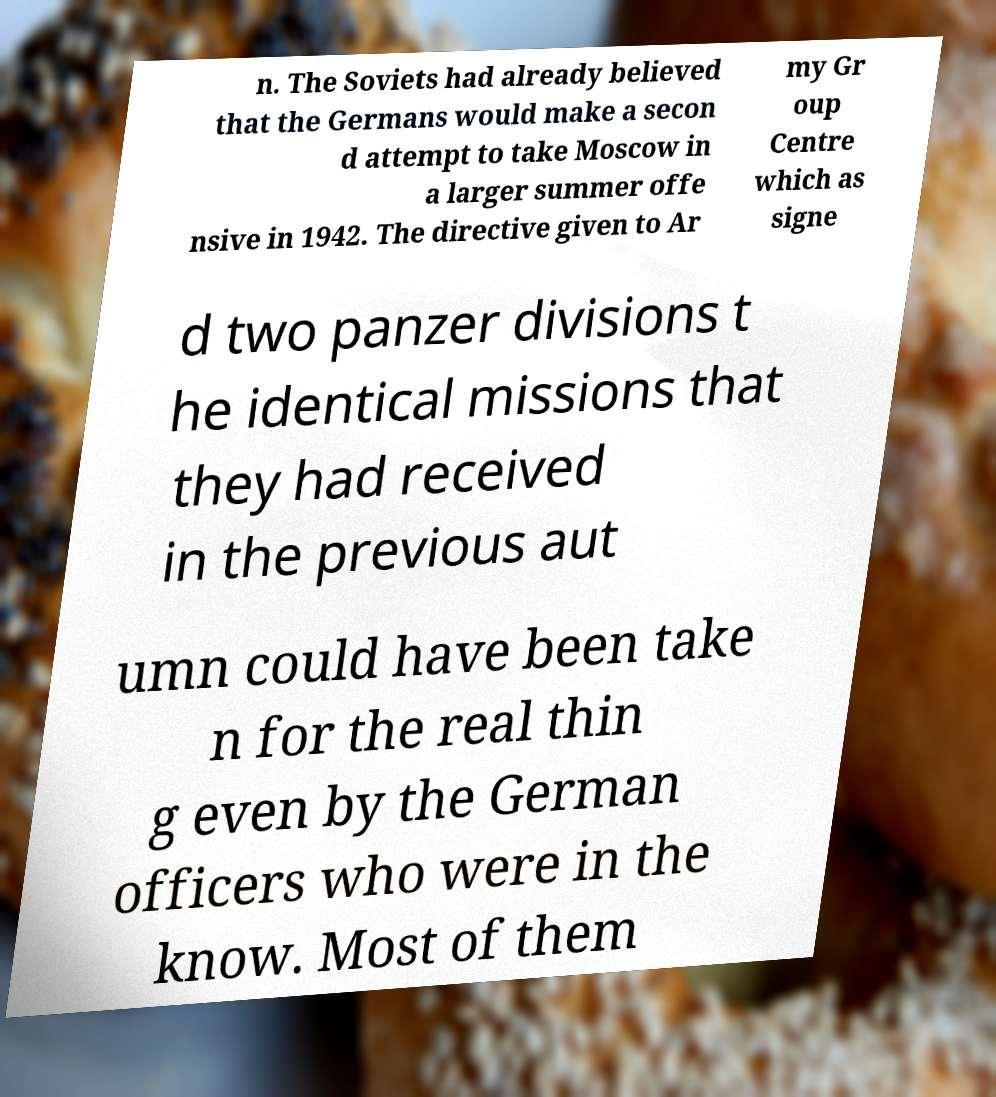There's text embedded in this image that I need extracted. Can you transcribe it verbatim? n. The Soviets had already believed that the Germans would make a secon d attempt to take Moscow in a larger summer offe nsive in 1942. The directive given to Ar my Gr oup Centre which as signe d two panzer divisions t he identical missions that they had received in the previous aut umn could have been take n for the real thin g even by the German officers who were in the know. Most of them 